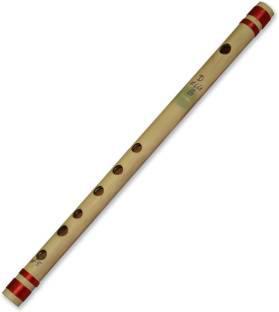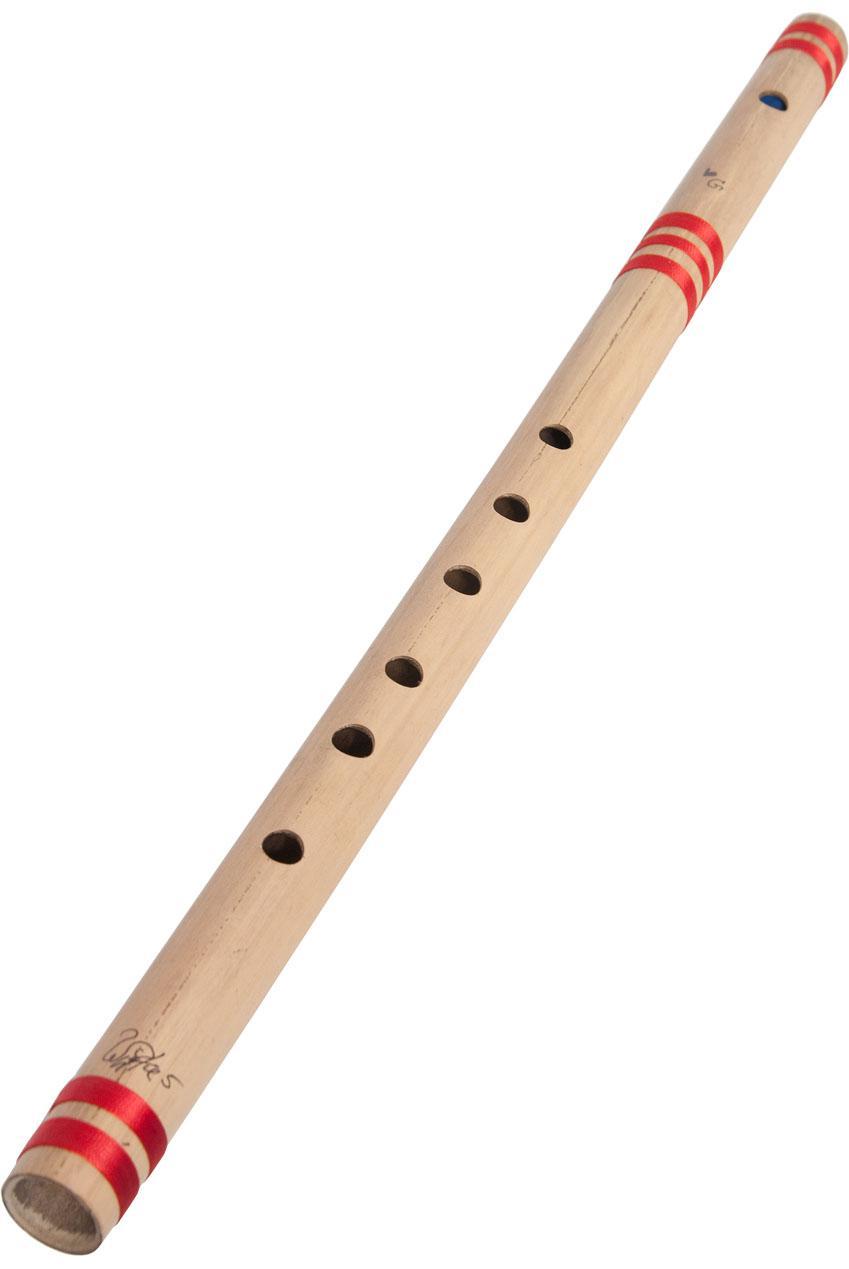The first image is the image on the left, the second image is the image on the right. Analyze the images presented: Is the assertion "There is one flute with red stripes and one flute without stripes." valid? Answer yes or no. No. The first image is the image on the left, the second image is the image on the right. Considering the images on both sides, is "There are two flutes." valid? Answer yes or no. Yes. 